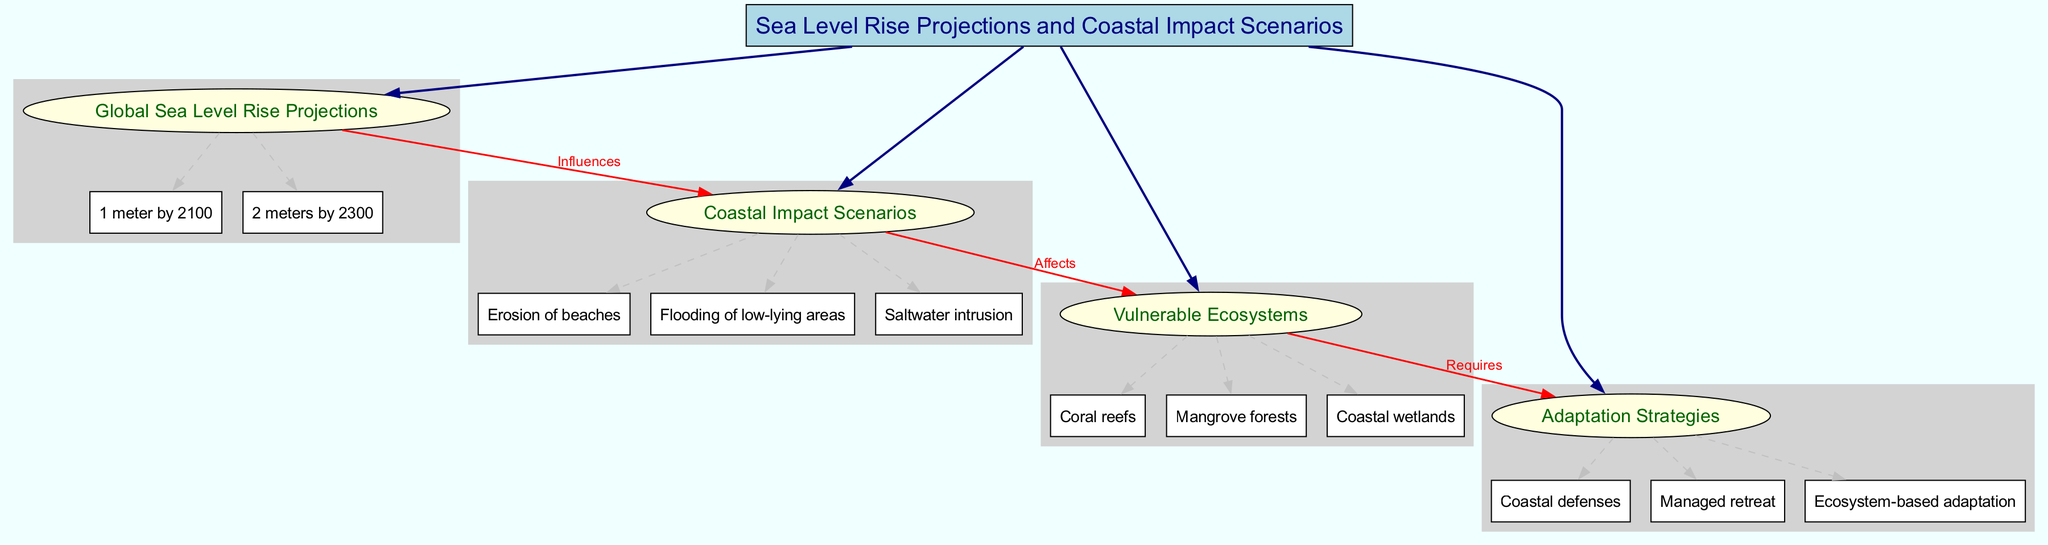What is the main topic of the diagram? The main topic is stated at the top of the diagram, directly labeled as "Sea Level Rise Projections and Coastal Impact Scenarios."
Answer: Sea Level Rise Projections and Coastal Impact Scenarios How many subtopics are in the diagram? Counting the listed subtopics within the diagram reveals a total of four: Global Sea Level Rise Projections, Coastal Impact Scenarios, Vulnerable Ecosystems, and Adaptation Strategies.
Answer: 4 What are the two sea level rise projections mentioned? The diagram specifies two projections: "1 meter by 2100" and "2 meters by 2300," as elements under the Global Sea Level Rise Projections subtopic.
Answer: 1 meter by 2100, 2 meters by 2300 What impacts does coastal scenarios have on vulnerable ecosystems? The diagram connects Coastal Impact Scenarios to Vulnerable Ecosystems with a direct label "Affects," emphasizing the relationship where coastal impacts directly result in effects on vulnerable ecosystems.
Answer: Affects Which adaptation strategy is needed due to vulnerable ecosystems? The diagram explicitly outlines that adaptation strategies are required by vulnerable ecosystems, showing a connection that labels "Requires" from Vulnerable Ecosystems to Adaptation Strategies.
Answer: Requires What type of coastal impact is specifically listed under Coastal Impact Scenarios? Under the Coastal Impact Scenarios, one specific type mentioned is "Erosion of beaches," which is noted as one of the elements within that subtopic.
Answer: Erosion of beaches What do the connections in the diagram indicate about relationships between subtopics? Connections in the diagram indicate how the projections influence impacts, and how these impacts affect ecosystems, reinforcing the interdependence among them. For example, "Global Sea Level Rise Projections" influences "Coastal Impact Scenarios," which in turn affects "Vulnerable Ecosystems."
Answer: Interdependence What is one of the vulnerable ecosystems mentioned in the diagram? The diagram lists three vulnerable ecosystems, and one of them is "Coral reefs," which is included as an element under the Vulnerable Ecosystems subtopic.
Answer: Coral reefs 